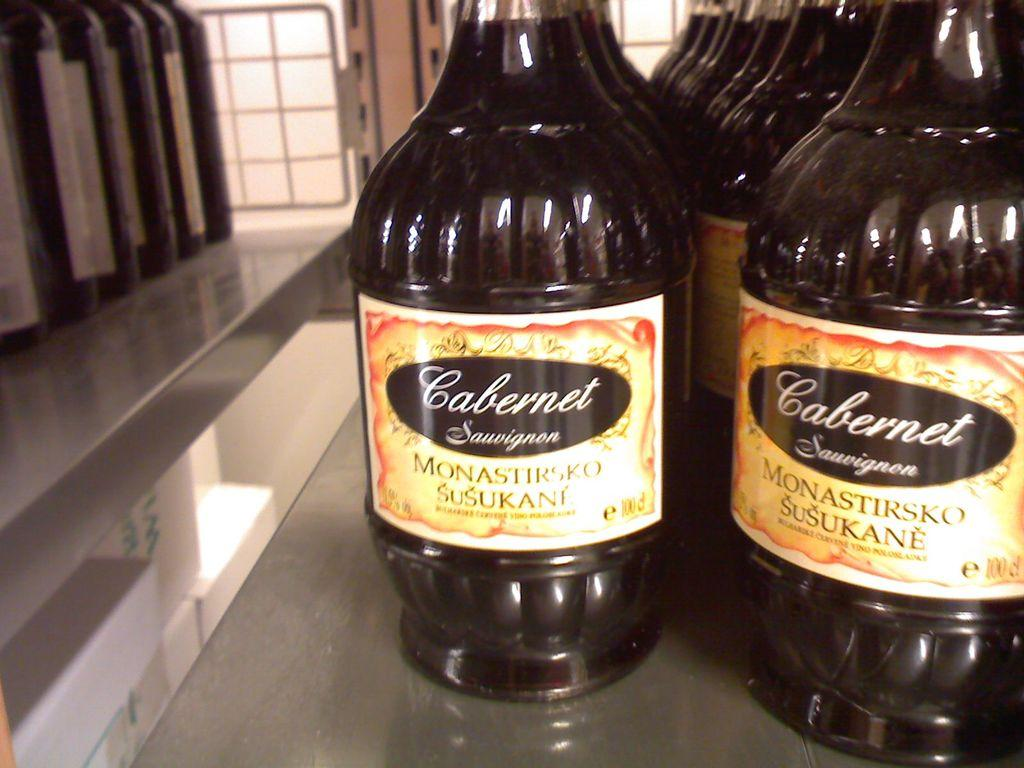<image>
Relay a brief, clear account of the picture shown. Numerous bottles of Cabernet Sauvignon sit on a glossy countertop. 